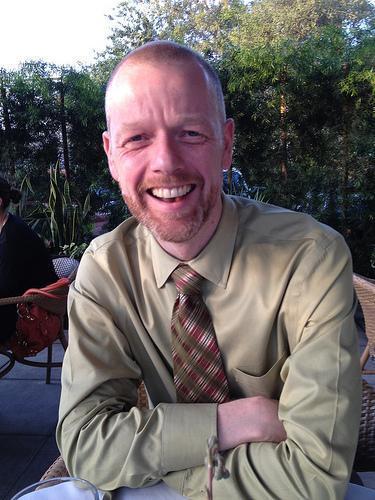How many people are there?
Give a very brief answer. 2. 